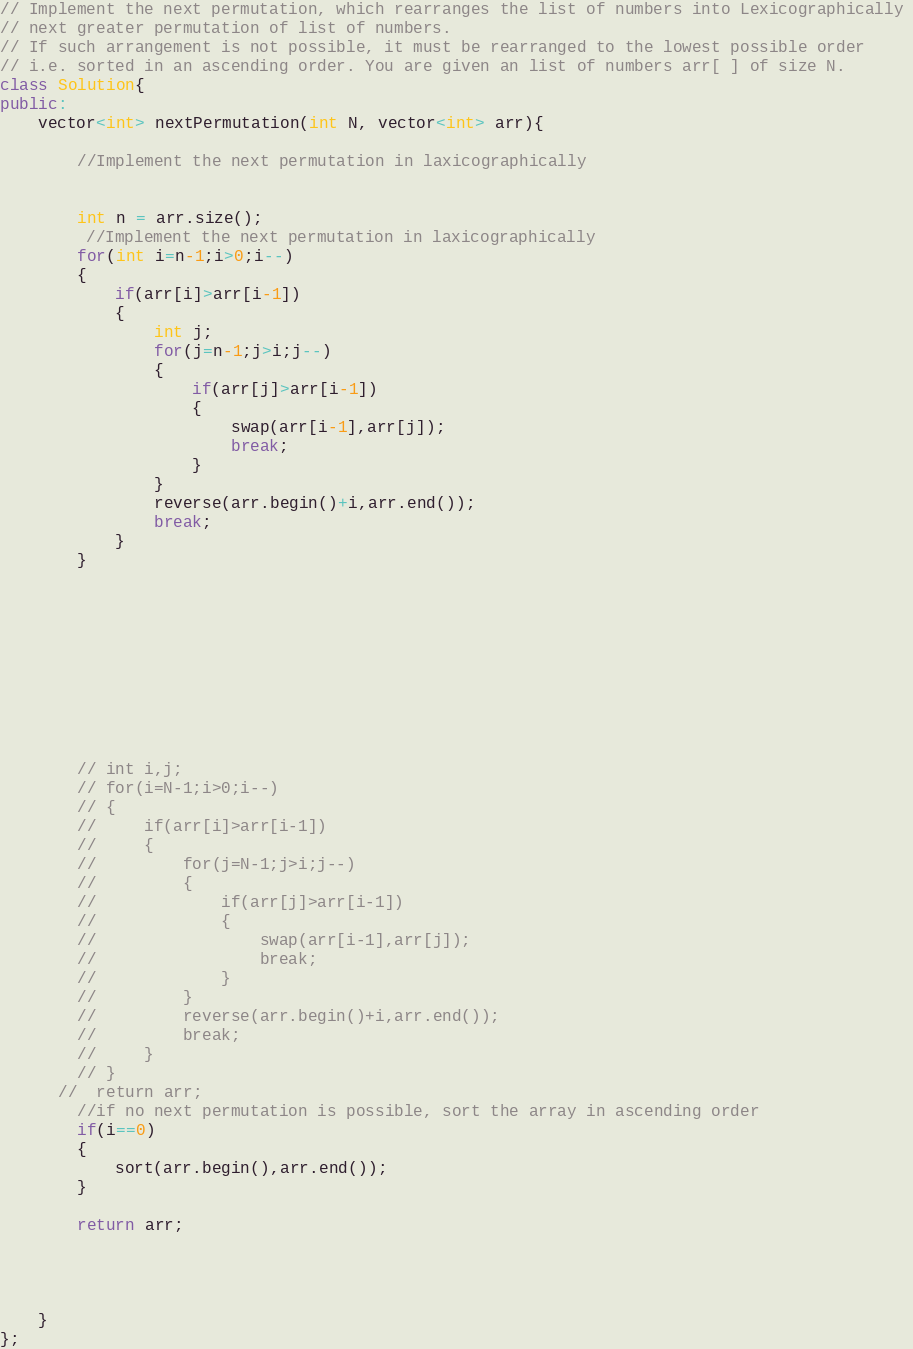Convert code to text. <code><loc_0><loc_0><loc_500><loc_500><_C++_>



// Implement the next permutation, which rearranges the list of numbers into Lexicographically 
// next greater permutation of list of numbers. 
// If such arrangement is not possible, it must be rearranged to the lowest possible order 
// i.e. sorted in an ascending order. You are given an list of numbers arr[ ] of size N.
class Solution{
public:
    vector<int> nextPermutation(int N, vector<int> arr){

        //Implement the next permutation in laxicographically


        int n = arr.size();
         //Implement the next permutation in laxicographically
        for(int i=n-1;i>0;i--)
        {
            if(arr[i]>arr[i-1])
            {
                int j;
                for(j=n-1;j>i;j--)
                {
                    if(arr[j]>arr[i-1])
                    {
                        swap(arr[i-1],arr[j]);
                        break;
                    }
                }
                reverse(arr.begin()+i,arr.end());
                break;
            }
        }










        // int i,j;
        // for(i=N-1;i>0;i--)
        // {
        //     if(arr[i]>arr[i-1])
        //     {
        //         for(j=N-1;j>i;j--)
        //         {
        //             if(arr[j]>arr[i-1])
        //             {
        //                 swap(arr[i-1],arr[j]);
        //                 break;
        //             }
        //         }
        //         reverse(arr.begin()+i,arr.end());
        //         break;
        //     }
        // }
      //  return arr;
        //if no next permutation is possible, sort the array in ascending order
        if(i==0)
        {
            sort(arr.begin(),arr.end());
        }

        return arr;




    }
};</code> 